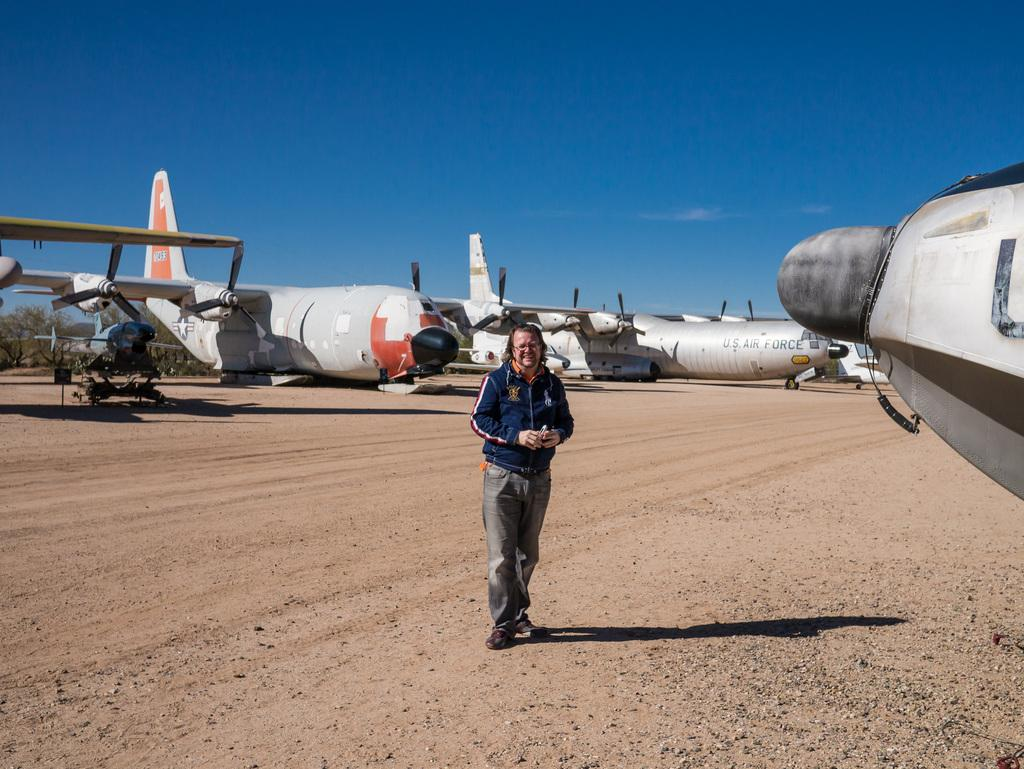What is the main subject of the image? There is a person on the ground in the image. What can be seen in the background of the image? There are airplanes, trees, and the sky visible in the background of the image. What type of pump is being used by the person in the image? There is no pump present in the image; it features a person on the ground with airplanes, trees, and the sky in the background. How many sides does the square have in the image? There is no square present in the image. 